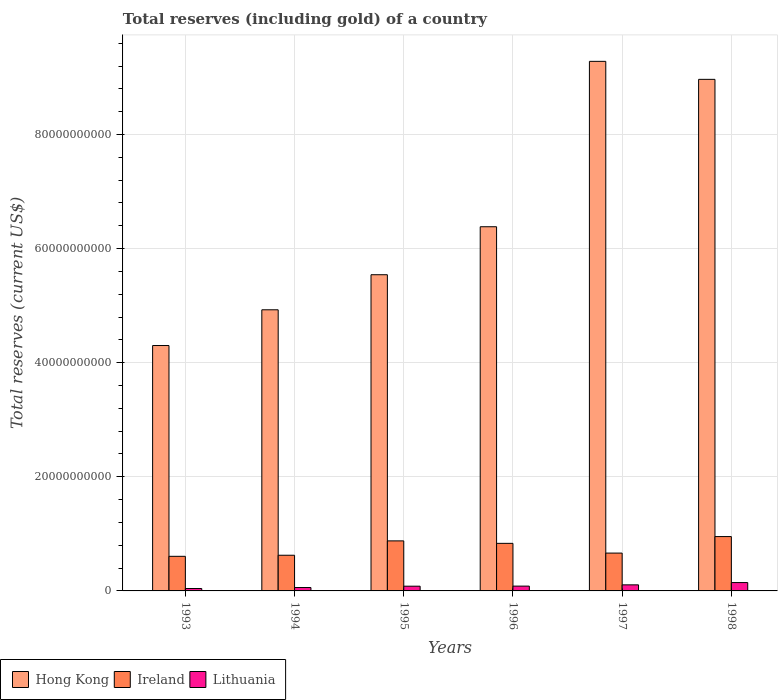How many different coloured bars are there?
Offer a very short reply. 3. How many groups of bars are there?
Provide a short and direct response. 6. Are the number of bars on each tick of the X-axis equal?
Give a very brief answer. Yes. How many bars are there on the 3rd tick from the left?
Offer a terse response. 3. In how many cases, is the number of bars for a given year not equal to the number of legend labels?
Keep it short and to the point. 0. What is the total reserves (including gold) in Hong Kong in 1993?
Your answer should be compact. 4.30e+1. Across all years, what is the maximum total reserves (including gold) in Ireland?
Your answer should be compact. 9.53e+09. Across all years, what is the minimum total reserves (including gold) in Hong Kong?
Provide a succinct answer. 4.30e+1. In which year was the total reserves (including gold) in Ireland maximum?
Your response must be concise. 1998. In which year was the total reserves (including gold) in Ireland minimum?
Your response must be concise. 1993. What is the total total reserves (including gold) in Lithuania in the graph?
Offer a terse response. 5.22e+09. What is the difference between the total reserves (including gold) in Ireland in 1996 and that in 1998?
Make the answer very short. -1.19e+09. What is the difference between the total reserves (including gold) in Ireland in 1998 and the total reserves (including gold) in Lithuania in 1995?
Keep it short and to the point. 8.70e+09. What is the average total reserves (including gold) in Hong Kong per year?
Your answer should be very brief. 6.57e+1. In the year 1995, what is the difference between the total reserves (including gold) in Ireland and total reserves (including gold) in Lithuania?
Give a very brief answer. 7.94e+09. What is the ratio of the total reserves (including gold) in Ireland in 1995 to that in 1996?
Your answer should be compact. 1.05. Is the total reserves (including gold) in Hong Kong in 1995 less than that in 1996?
Make the answer very short. Yes. What is the difference between the highest and the second highest total reserves (including gold) in Hong Kong?
Your answer should be very brief. 3.15e+09. What is the difference between the highest and the lowest total reserves (including gold) in Ireland?
Offer a very short reply. 3.46e+09. In how many years, is the total reserves (including gold) in Lithuania greater than the average total reserves (including gold) in Lithuania taken over all years?
Keep it short and to the point. 2. Is the sum of the total reserves (including gold) in Hong Kong in 1994 and 1998 greater than the maximum total reserves (including gold) in Lithuania across all years?
Keep it short and to the point. Yes. What does the 2nd bar from the left in 1995 represents?
Offer a very short reply. Ireland. What does the 3rd bar from the right in 1998 represents?
Keep it short and to the point. Hong Kong. Is it the case that in every year, the sum of the total reserves (including gold) in Hong Kong and total reserves (including gold) in Lithuania is greater than the total reserves (including gold) in Ireland?
Your response must be concise. Yes. How many bars are there?
Offer a terse response. 18. How many years are there in the graph?
Your answer should be very brief. 6. What is the difference between two consecutive major ticks on the Y-axis?
Offer a terse response. 2.00e+1. Are the values on the major ticks of Y-axis written in scientific E-notation?
Ensure brevity in your answer.  No. Does the graph contain any zero values?
Offer a terse response. No. Does the graph contain grids?
Provide a succinct answer. Yes. Where does the legend appear in the graph?
Provide a short and direct response. Bottom left. How many legend labels are there?
Offer a very short reply. 3. How are the legend labels stacked?
Keep it short and to the point. Horizontal. What is the title of the graph?
Make the answer very short. Total reserves (including gold) of a country. What is the label or title of the Y-axis?
Your answer should be compact. Total reserves (current US$). What is the Total reserves (current US$) of Hong Kong in 1993?
Offer a terse response. 4.30e+1. What is the Total reserves (current US$) in Ireland in 1993?
Offer a terse response. 6.07e+09. What is the Total reserves (current US$) of Lithuania in 1993?
Ensure brevity in your answer.  4.23e+08. What is the Total reserves (current US$) in Hong Kong in 1994?
Make the answer very short. 4.93e+1. What is the Total reserves (current US$) in Ireland in 1994?
Your response must be concise. 6.25e+09. What is the Total reserves (current US$) of Lithuania in 1994?
Make the answer very short. 5.97e+08. What is the Total reserves (current US$) of Hong Kong in 1995?
Make the answer very short. 5.54e+1. What is the Total reserves (current US$) of Ireland in 1995?
Offer a very short reply. 8.77e+09. What is the Total reserves (current US$) of Lithuania in 1995?
Ensure brevity in your answer.  8.29e+08. What is the Total reserves (current US$) of Hong Kong in 1996?
Offer a terse response. 6.38e+1. What is the Total reserves (current US$) of Ireland in 1996?
Make the answer very short. 8.34e+09. What is the Total reserves (current US$) of Lithuania in 1996?
Provide a succinct answer. 8.41e+08. What is the Total reserves (current US$) of Hong Kong in 1997?
Offer a terse response. 9.28e+1. What is the Total reserves (current US$) in Ireland in 1997?
Ensure brevity in your answer.  6.63e+09. What is the Total reserves (current US$) in Lithuania in 1997?
Provide a succinct answer. 1.06e+09. What is the Total reserves (current US$) in Hong Kong in 1998?
Give a very brief answer. 8.97e+1. What is the Total reserves (current US$) of Ireland in 1998?
Offer a very short reply. 9.53e+09. What is the Total reserves (current US$) in Lithuania in 1998?
Provide a succinct answer. 1.46e+09. Across all years, what is the maximum Total reserves (current US$) in Hong Kong?
Offer a very short reply. 9.28e+1. Across all years, what is the maximum Total reserves (current US$) of Ireland?
Provide a succinct answer. 9.53e+09. Across all years, what is the maximum Total reserves (current US$) in Lithuania?
Make the answer very short. 1.46e+09. Across all years, what is the minimum Total reserves (current US$) of Hong Kong?
Provide a succinct answer. 4.30e+1. Across all years, what is the minimum Total reserves (current US$) of Ireland?
Keep it short and to the point. 6.07e+09. Across all years, what is the minimum Total reserves (current US$) of Lithuania?
Make the answer very short. 4.23e+08. What is the total Total reserves (current US$) in Hong Kong in the graph?
Offer a terse response. 3.94e+11. What is the total Total reserves (current US$) in Ireland in the graph?
Offer a terse response. 4.56e+1. What is the total Total reserves (current US$) in Lithuania in the graph?
Your response must be concise. 5.22e+09. What is the difference between the Total reserves (current US$) of Hong Kong in 1993 and that in 1994?
Make the answer very short. -6.26e+09. What is the difference between the Total reserves (current US$) in Ireland in 1993 and that in 1994?
Give a very brief answer. -1.87e+08. What is the difference between the Total reserves (current US$) of Lithuania in 1993 and that in 1994?
Your answer should be very brief. -1.74e+08. What is the difference between the Total reserves (current US$) of Hong Kong in 1993 and that in 1995?
Your response must be concise. -1.24e+1. What is the difference between the Total reserves (current US$) of Ireland in 1993 and that in 1995?
Ensure brevity in your answer.  -2.70e+09. What is the difference between the Total reserves (current US$) of Lithuania in 1993 and that in 1995?
Make the answer very short. -4.06e+08. What is the difference between the Total reserves (current US$) of Hong Kong in 1993 and that in 1996?
Your answer should be very brief. -2.08e+1. What is the difference between the Total reserves (current US$) of Ireland in 1993 and that in 1996?
Make the answer very short. -2.27e+09. What is the difference between the Total reserves (current US$) in Lithuania in 1993 and that in 1996?
Keep it short and to the point. -4.18e+08. What is the difference between the Total reserves (current US$) of Hong Kong in 1993 and that in 1997?
Provide a succinct answer. -4.98e+1. What is the difference between the Total reserves (current US$) in Ireland in 1993 and that in 1997?
Give a very brief answer. -5.65e+08. What is the difference between the Total reserves (current US$) of Lithuania in 1993 and that in 1997?
Your response must be concise. -6.41e+08. What is the difference between the Total reserves (current US$) of Hong Kong in 1993 and that in 1998?
Make the answer very short. -4.67e+1. What is the difference between the Total reserves (current US$) in Ireland in 1993 and that in 1998?
Your answer should be compact. -3.46e+09. What is the difference between the Total reserves (current US$) of Lithuania in 1993 and that in 1998?
Ensure brevity in your answer.  -1.04e+09. What is the difference between the Total reserves (current US$) of Hong Kong in 1994 and that in 1995?
Offer a very short reply. -6.15e+09. What is the difference between the Total reserves (current US$) of Ireland in 1994 and that in 1995?
Provide a succinct answer. -2.52e+09. What is the difference between the Total reserves (current US$) of Lithuania in 1994 and that in 1995?
Your response must be concise. -2.32e+08. What is the difference between the Total reserves (current US$) in Hong Kong in 1994 and that in 1996?
Make the answer very short. -1.46e+1. What is the difference between the Total reserves (current US$) of Ireland in 1994 and that in 1996?
Your answer should be very brief. -2.09e+09. What is the difference between the Total reserves (current US$) in Lithuania in 1994 and that in 1996?
Your answer should be compact. -2.44e+08. What is the difference between the Total reserves (current US$) in Hong Kong in 1994 and that in 1997?
Provide a short and direct response. -4.35e+1. What is the difference between the Total reserves (current US$) in Ireland in 1994 and that in 1997?
Your answer should be compact. -3.78e+08. What is the difference between the Total reserves (current US$) in Lithuania in 1994 and that in 1997?
Make the answer very short. -4.67e+08. What is the difference between the Total reserves (current US$) of Hong Kong in 1994 and that in 1998?
Make the answer very short. -4.04e+1. What is the difference between the Total reserves (current US$) in Ireland in 1994 and that in 1998?
Your answer should be very brief. -3.27e+09. What is the difference between the Total reserves (current US$) of Lithuania in 1994 and that in 1998?
Offer a terse response. -8.66e+08. What is the difference between the Total reserves (current US$) in Hong Kong in 1995 and that in 1996?
Offer a terse response. -8.41e+09. What is the difference between the Total reserves (current US$) of Ireland in 1995 and that in 1996?
Your answer should be compact. 4.31e+08. What is the difference between the Total reserves (current US$) of Lithuania in 1995 and that in 1996?
Offer a very short reply. -1.21e+07. What is the difference between the Total reserves (current US$) of Hong Kong in 1995 and that in 1997?
Your response must be concise. -3.74e+1. What is the difference between the Total reserves (current US$) in Ireland in 1995 and that in 1997?
Your response must be concise. 2.14e+09. What is the difference between the Total reserves (current US$) of Lithuania in 1995 and that in 1997?
Your answer should be compact. -2.35e+08. What is the difference between the Total reserves (current US$) in Hong Kong in 1995 and that in 1998?
Your answer should be very brief. -3.42e+1. What is the difference between the Total reserves (current US$) of Ireland in 1995 and that in 1998?
Your response must be concise. -7.57e+08. What is the difference between the Total reserves (current US$) in Lithuania in 1995 and that in 1998?
Offer a terse response. -6.34e+08. What is the difference between the Total reserves (current US$) in Hong Kong in 1996 and that in 1997?
Ensure brevity in your answer.  -2.90e+1. What is the difference between the Total reserves (current US$) in Ireland in 1996 and that in 1997?
Offer a very short reply. 1.71e+09. What is the difference between the Total reserves (current US$) in Lithuania in 1996 and that in 1997?
Make the answer very short. -2.23e+08. What is the difference between the Total reserves (current US$) of Hong Kong in 1996 and that in 1998?
Make the answer very short. -2.58e+1. What is the difference between the Total reserves (current US$) of Ireland in 1996 and that in 1998?
Provide a short and direct response. -1.19e+09. What is the difference between the Total reserves (current US$) in Lithuania in 1996 and that in 1998?
Your response must be concise. -6.22e+08. What is the difference between the Total reserves (current US$) in Hong Kong in 1997 and that in 1998?
Provide a succinct answer. 3.15e+09. What is the difference between the Total reserves (current US$) in Ireland in 1997 and that in 1998?
Your answer should be compact. -2.90e+09. What is the difference between the Total reserves (current US$) of Lithuania in 1997 and that in 1998?
Keep it short and to the point. -3.99e+08. What is the difference between the Total reserves (current US$) in Hong Kong in 1993 and the Total reserves (current US$) in Ireland in 1994?
Give a very brief answer. 3.68e+1. What is the difference between the Total reserves (current US$) in Hong Kong in 1993 and the Total reserves (current US$) in Lithuania in 1994?
Your answer should be compact. 4.24e+1. What is the difference between the Total reserves (current US$) in Ireland in 1993 and the Total reserves (current US$) in Lithuania in 1994?
Offer a very short reply. 5.47e+09. What is the difference between the Total reserves (current US$) of Hong Kong in 1993 and the Total reserves (current US$) of Ireland in 1995?
Ensure brevity in your answer.  3.42e+1. What is the difference between the Total reserves (current US$) of Hong Kong in 1993 and the Total reserves (current US$) of Lithuania in 1995?
Your response must be concise. 4.22e+1. What is the difference between the Total reserves (current US$) in Ireland in 1993 and the Total reserves (current US$) in Lithuania in 1995?
Keep it short and to the point. 5.24e+09. What is the difference between the Total reserves (current US$) in Hong Kong in 1993 and the Total reserves (current US$) in Ireland in 1996?
Offer a terse response. 3.47e+1. What is the difference between the Total reserves (current US$) of Hong Kong in 1993 and the Total reserves (current US$) of Lithuania in 1996?
Your answer should be compact. 4.22e+1. What is the difference between the Total reserves (current US$) of Ireland in 1993 and the Total reserves (current US$) of Lithuania in 1996?
Ensure brevity in your answer.  5.22e+09. What is the difference between the Total reserves (current US$) of Hong Kong in 1993 and the Total reserves (current US$) of Ireland in 1997?
Offer a very short reply. 3.64e+1. What is the difference between the Total reserves (current US$) of Hong Kong in 1993 and the Total reserves (current US$) of Lithuania in 1997?
Offer a very short reply. 4.19e+1. What is the difference between the Total reserves (current US$) in Ireland in 1993 and the Total reserves (current US$) in Lithuania in 1997?
Ensure brevity in your answer.  5.00e+09. What is the difference between the Total reserves (current US$) of Hong Kong in 1993 and the Total reserves (current US$) of Ireland in 1998?
Your answer should be very brief. 3.35e+1. What is the difference between the Total reserves (current US$) of Hong Kong in 1993 and the Total reserves (current US$) of Lithuania in 1998?
Give a very brief answer. 4.15e+1. What is the difference between the Total reserves (current US$) of Ireland in 1993 and the Total reserves (current US$) of Lithuania in 1998?
Provide a short and direct response. 4.60e+09. What is the difference between the Total reserves (current US$) in Hong Kong in 1994 and the Total reserves (current US$) in Ireland in 1995?
Keep it short and to the point. 4.05e+1. What is the difference between the Total reserves (current US$) in Hong Kong in 1994 and the Total reserves (current US$) in Lithuania in 1995?
Make the answer very short. 4.84e+1. What is the difference between the Total reserves (current US$) in Ireland in 1994 and the Total reserves (current US$) in Lithuania in 1995?
Your response must be concise. 5.42e+09. What is the difference between the Total reserves (current US$) of Hong Kong in 1994 and the Total reserves (current US$) of Ireland in 1996?
Your answer should be very brief. 4.09e+1. What is the difference between the Total reserves (current US$) in Hong Kong in 1994 and the Total reserves (current US$) in Lithuania in 1996?
Offer a very short reply. 4.84e+1. What is the difference between the Total reserves (current US$) of Ireland in 1994 and the Total reserves (current US$) of Lithuania in 1996?
Ensure brevity in your answer.  5.41e+09. What is the difference between the Total reserves (current US$) in Hong Kong in 1994 and the Total reserves (current US$) in Ireland in 1997?
Make the answer very short. 4.26e+1. What is the difference between the Total reserves (current US$) in Hong Kong in 1994 and the Total reserves (current US$) in Lithuania in 1997?
Keep it short and to the point. 4.82e+1. What is the difference between the Total reserves (current US$) in Ireland in 1994 and the Total reserves (current US$) in Lithuania in 1997?
Provide a succinct answer. 5.19e+09. What is the difference between the Total reserves (current US$) of Hong Kong in 1994 and the Total reserves (current US$) of Ireland in 1998?
Provide a short and direct response. 3.97e+1. What is the difference between the Total reserves (current US$) of Hong Kong in 1994 and the Total reserves (current US$) of Lithuania in 1998?
Provide a succinct answer. 4.78e+1. What is the difference between the Total reserves (current US$) of Ireland in 1994 and the Total reserves (current US$) of Lithuania in 1998?
Give a very brief answer. 4.79e+09. What is the difference between the Total reserves (current US$) in Hong Kong in 1995 and the Total reserves (current US$) in Ireland in 1996?
Provide a succinct answer. 4.71e+1. What is the difference between the Total reserves (current US$) of Hong Kong in 1995 and the Total reserves (current US$) of Lithuania in 1996?
Give a very brief answer. 5.46e+1. What is the difference between the Total reserves (current US$) in Ireland in 1995 and the Total reserves (current US$) in Lithuania in 1996?
Keep it short and to the point. 7.93e+09. What is the difference between the Total reserves (current US$) in Hong Kong in 1995 and the Total reserves (current US$) in Ireland in 1997?
Provide a succinct answer. 4.88e+1. What is the difference between the Total reserves (current US$) in Hong Kong in 1995 and the Total reserves (current US$) in Lithuania in 1997?
Your answer should be compact. 5.44e+1. What is the difference between the Total reserves (current US$) of Ireland in 1995 and the Total reserves (current US$) of Lithuania in 1997?
Keep it short and to the point. 7.71e+09. What is the difference between the Total reserves (current US$) of Hong Kong in 1995 and the Total reserves (current US$) of Ireland in 1998?
Your answer should be compact. 4.59e+1. What is the difference between the Total reserves (current US$) of Hong Kong in 1995 and the Total reserves (current US$) of Lithuania in 1998?
Your answer should be compact. 5.40e+1. What is the difference between the Total reserves (current US$) in Ireland in 1995 and the Total reserves (current US$) in Lithuania in 1998?
Keep it short and to the point. 7.31e+09. What is the difference between the Total reserves (current US$) in Hong Kong in 1996 and the Total reserves (current US$) in Ireland in 1997?
Ensure brevity in your answer.  5.72e+1. What is the difference between the Total reserves (current US$) of Hong Kong in 1996 and the Total reserves (current US$) of Lithuania in 1997?
Provide a succinct answer. 6.28e+1. What is the difference between the Total reserves (current US$) in Ireland in 1996 and the Total reserves (current US$) in Lithuania in 1997?
Your answer should be very brief. 7.27e+09. What is the difference between the Total reserves (current US$) of Hong Kong in 1996 and the Total reserves (current US$) of Ireland in 1998?
Your answer should be compact. 5.43e+1. What is the difference between the Total reserves (current US$) in Hong Kong in 1996 and the Total reserves (current US$) in Lithuania in 1998?
Your answer should be very brief. 6.24e+1. What is the difference between the Total reserves (current US$) of Ireland in 1996 and the Total reserves (current US$) of Lithuania in 1998?
Provide a short and direct response. 6.88e+09. What is the difference between the Total reserves (current US$) in Hong Kong in 1997 and the Total reserves (current US$) in Ireland in 1998?
Your answer should be very brief. 8.33e+1. What is the difference between the Total reserves (current US$) in Hong Kong in 1997 and the Total reserves (current US$) in Lithuania in 1998?
Provide a short and direct response. 9.14e+1. What is the difference between the Total reserves (current US$) in Ireland in 1997 and the Total reserves (current US$) in Lithuania in 1998?
Keep it short and to the point. 5.17e+09. What is the average Total reserves (current US$) in Hong Kong per year?
Provide a succinct answer. 6.57e+1. What is the average Total reserves (current US$) of Ireland per year?
Provide a short and direct response. 7.60e+09. What is the average Total reserves (current US$) in Lithuania per year?
Offer a very short reply. 8.69e+08. In the year 1993, what is the difference between the Total reserves (current US$) in Hong Kong and Total reserves (current US$) in Ireland?
Ensure brevity in your answer.  3.69e+1. In the year 1993, what is the difference between the Total reserves (current US$) in Hong Kong and Total reserves (current US$) in Lithuania?
Make the answer very short. 4.26e+1. In the year 1993, what is the difference between the Total reserves (current US$) of Ireland and Total reserves (current US$) of Lithuania?
Provide a succinct answer. 5.64e+09. In the year 1994, what is the difference between the Total reserves (current US$) of Hong Kong and Total reserves (current US$) of Ireland?
Give a very brief answer. 4.30e+1. In the year 1994, what is the difference between the Total reserves (current US$) in Hong Kong and Total reserves (current US$) in Lithuania?
Your answer should be compact. 4.87e+1. In the year 1994, what is the difference between the Total reserves (current US$) of Ireland and Total reserves (current US$) of Lithuania?
Give a very brief answer. 5.66e+09. In the year 1995, what is the difference between the Total reserves (current US$) of Hong Kong and Total reserves (current US$) of Ireland?
Your answer should be very brief. 4.67e+1. In the year 1995, what is the difference between the Total reserves (current US$) in Hong Kong and Total reserves (current US$) in Lithuania?
Make the answer very short. 5.46e+1. In the year 1995, what is the difference between the Total reserves (current US$) in Ireland and Total reserves (current US$) in Lithuania?
Provide a succinct answer. 7.94e+09. In the year 1996, what is the difference between the Total reserves (current US$) of Hong Kong and Total reserves (current US$) of Ireland?
Make the answer very short. 5.55e+1. In the year 1996, what is the difference between the Total reserves (current US$) of Hong Kong and Total reserves (current US$) of Lithuania?
Offer a terse response. 6.30e+1. In the year 1996, what is the difference between the Total reserves (current US$) in Ireland and Total reserves (current US$) in Lithuania?
Provide a short and direct response. 7.50e+09. In the year 1997, what is the difference between the Total reserves (current US$) of Hong Kong and Total reserves (current US$) of Ireland?
Give a very brief answer. 8.62e+1. In the year 1997, what is the difference between the Total reserves (current US$) of Hong Kong and Total reserves (current US$) of Lithuania?
Offer a very short reply. 9.18e+1. In the year 1997, what is the difference between the Total reserves (current US$) of Ireland and Total reserves (current US$) of Lithuania?
Your answer should be compact. 5.57e+09. In the year 1998, what is the difference between the Total reserves (current US$) of Hong Kong and Total reserves (current US$) of Ireland?
Your response must be concise. 8.01e+1. In the year 1998, what is the difference between the Total reserves (current US$) of Hong Kong and Total reserves (current US$) of Lithuania?
Provide a short and direct response. 8.82e+1. In the year 1998, what is the difference between the Total reserves (current US$) of Ireland and Total reserves (current US$) of Lithuania?
Provide a succinct answer. 8.06e+09. What is the ratio of the Total reserves (current US$) of Hong Kong in 1993 to that in 1994?
Provide a short and direct response. 0.87. What is the ratio of the Total reserves (current US$) of Ireland in 1993 to that in 1994?
Provide a succinct answer. 0.97. What is the ratio of the Total reserves (current US$) in Lithuania in 1993 to that in 1994?
Offer a very short reply. 0.71. What is the ratio of the Total reserves (current US$) in Hong Kong in 1993 to that in 1995?
Make the answer very short. 0.78. What is the ratio of the Total reserves (current US$) of Ireland in 1993 to that in 1995?
Give a very brief answer. 0.69. What is the ratio of the Total reserves (current US$) in Lithuania in 1993 to that in 1995?
Offer a very short reply. 0.51. What is the ratio of the Total reserves (current US$) in Hong Kong in 1993 to that in 1996?
Offer a very short reply. 0.67. What is the ratio of the Total reserves (current US$) of Ireland in 1993 to that in 1996?
Your answer should be compact. 0.73. What is the ratio of the Total reserves (current US$) in Lithuania in 1993 to that in 1996?
Your answer should be very brief. 0.5. What is the ratio of the Total reserves (current US$) of Hong Kong in 1993 to that in 1997?
Your answer should be very brief. 0.46. What is the ratio of the Total reserves (current US$) in Ireland in 1993 to that in 1997?
Your response must be concise. 0.91. What is the ratio of the Total reserves (current US$) of Lithuania in 1993 to that in 1997?
Keep it short and to the point. 0.4. What is the ratio of the Total reserves (current US$) of Hong Kong in 1993 to that in 1998?
Your answer should be compact. 0.48. What is the ratio of the Total reserves (current US$) in Ireland in 1993 to that in 1998?
Offer a terse response. 0.64. What is the ratio of the Total reserves (current US$) of Lithuania in 1993 to that in 1998?
Keep it short and to the point. 0.29. What is the ratio of the Total reserves (current US$) in Hong Kong in 1994 to that in 1995?
Keep it short and to the point. 0.89. What is the ratio of the Total reserves (current US$) in Ireland in 1994 to that in 1995?
Your answer should be compact. 0.71. What is the ratio of the Total reserves (current US$) in Lithuania in 1994 to that in 1995?
Your answer should be very brief. 0.72. What is the ratio of the Total reserves (current US$) in Hong Kong in 1994 to that in 1996?
Make the answer very short. 0.77. What is the ratio of the Total reserves (current US$) in Ireland in 1994 to that in 1996?
Offer a terse response. 0.75. What is the ratio of the Total reserves (current US$) of Lithuania in 1994 to that in 1996?
Your answer should be compact. 0.71. What is the ratio of the Total reserves (current US$) in Hong Kong in 1994 to that in 1997?
Ensure brevity in your answer.  0.53. What is the ratio of the Total reserves (current US$) of Ireland in 1994 to that in 1997?
Provide a succinct answer. 0.94. What is the ratio of the Total reserves (current US$) of Lithuania in 1994 to that in 1997?
Your response must be concise. 0.56. What is the ratio of the Total reserves (current US$) of Hong Kong in 1994 to that in 1998?
Your response must be concise. 0.55. What is the ratio of the Total reserves (current US$) of Ireland in 1994 to that in 1998?
Your answer should be very brief. 0.66. What is the ratio of the Total reserves (current US$) in Lithuania in 1994 to that in 1998?
Your answer should be very brief. 0.41. What is the ratio of the Total reserves (current US$) in Hong Kong in 1995 to that in 1996?
Your answer should be compact. 0.87. What is the ratio of the Total reserves (current US$) of Ireland in 1995 to that in 1996?
Offer a very short reply. 1.05. What is the ratio of the Total reserves (current US$) in Lithuania in 1995 to that in 1996?
Keep it short and to the point. 0.99. What is the ratio of the Total reserves (current US$) of Hong Kong in 1995 to that in 1997?
Give a very brief answer. 0.6. What is the ratio of the Total reserves (current US$) in Ireland in 1995 to that in 1997?
Give a very brief answer. 1.32. What is the ratio of the Total reserves (current US$) in Lithuania in 1995 to that in 1997?
Provide a short and direct response. 0.78. What is the ratio of the Total reserves (current US$) in Hong Kong in 1995 to that in 1998?
Give a very brief answer. 0.62. What is the ratio of the Total reserves (current US$) of Ireland in 1995 to that in 1998?
Ensure brevity in your answer.  0.92. What is the ratio of the Total reserves (current US$) of Lithuania in 1995 to that in 1998?
Ensure brevity in your answer.  0.57. What is the ratio of the Total reserves (current US$) in Hong Kong in 1996 to that in 1997?
Your answer should be very brief. 0.69. What is the ratio of the Total reserves (current US$) of Ireland in 1996 to that in 1997?
Your answer should be compact. 1.26. What is the ratio of the Total reserves (current US$) of Lithuania in 1996 to that in 1997?
Give a very brief answer. 0.79. What is the ratio of the Total reserves (current US$) of Hong Kong in 1996 to that in 1998?
Give a very brief answer. 0.71. What is the ratio of the Total reserves (current US$) in Ireland in 1996 to that in 1998?
Give a very brief answer. 0.88. What is the ratio of the Total reserves (current US$) in Lithuania in 1996 to that in 1998?
Ensure brevity in your answer.  0.57. What is the ratio of the Total reserves (current US$) of Hong Kong in 1997 to that in 1998?
Your answer should be compact. 1.04. What is the ratio of the Total reserves (current US$) in Ireland in 1997 to that in 1998?
Your response must be concise. 0.7. What is the ratio of the Total reserves (current US$) in Lithuania in 1997 to that in 1998?
Your answer should be compact. 0.73. What is the difference between the highest and the second highest Total reserves (current US$) in Hong Kong?
Your answer should be very brief. 3.15e+09. What is the difference between the highest and the second highest Total reserves (current US$) in Ireland?
Make the answer very short. 7.57e+08. What is the difference between the highest and the second highest Total reserves (current US$) of Lithuania?
Your response must be concise. 3.99e+08. What is the difference between the highest and the lowest Total reserves (current US$) in Hong Kong?
Your answer should be very brief. 4.98e+1. What is the difference between the highest and the lowest Total reserves (current US$) of Ireland?
Your response must be concise. 3.46e+09. What is the difference between the highest and the lowest Total reserves (current US$) of Lithuania?
Your response must be concise. 1.04e+09. 